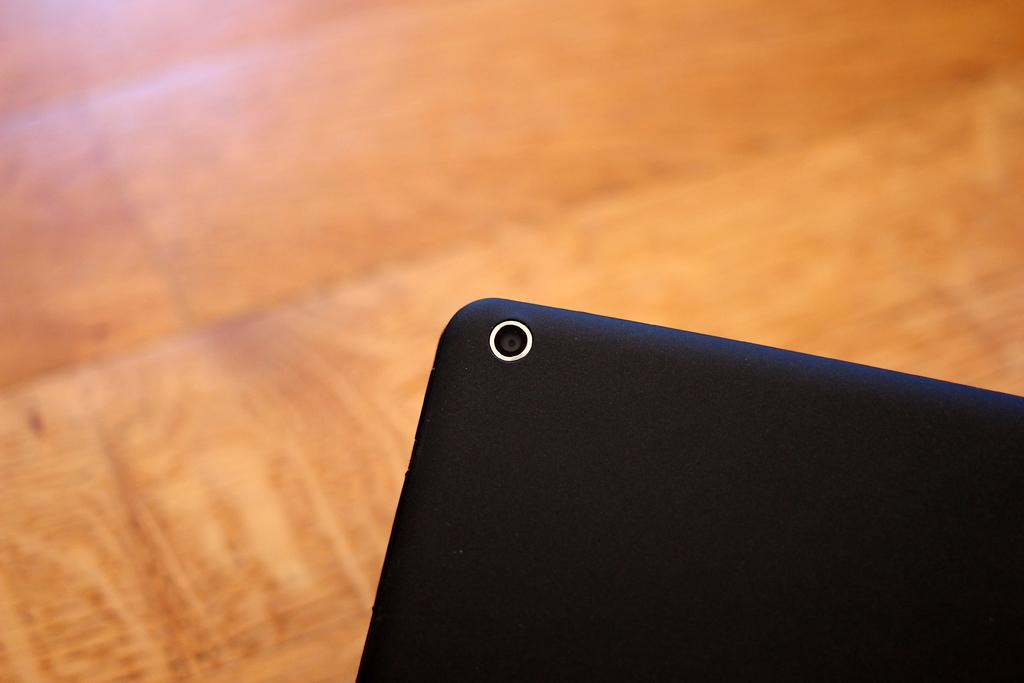What can be seen in the image? There is a device in the image. Can you describe the background of the image? There is a surface visible in the background of the image. What color is the crayon being used by the dog in the image? There is no dog or crayon present in the image. 